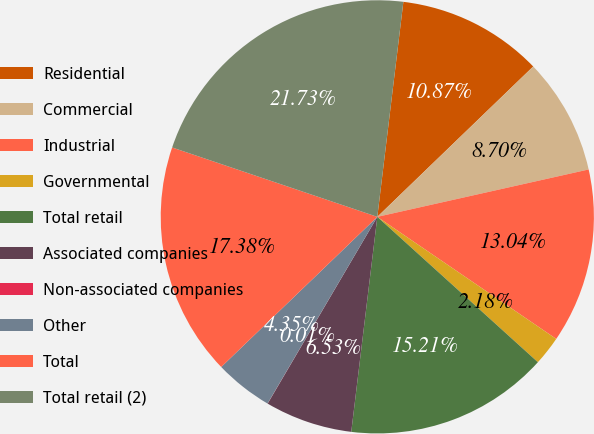Convert chart. <chart><loc_0><loc_0><loc_500><loc_500><pie_chart><fcel>Residential<fcel>Commercial<fcel>Industrial<fcel>Governmental<fcel>Total retail<fcel>Associated companies<fcel>Non-associated companies<fcel>Other<fcel>Total<fcel>Total retail (2)<nl><fcel>10.87%<fcel>8.7%<fcel>13.04%<fcel>2.18%<fcel>15.21%<fcel>6.53%<fcel>0.01%<fcel>4.35%<fcel>17.38%<fcel>21.73%<nl></chart> 